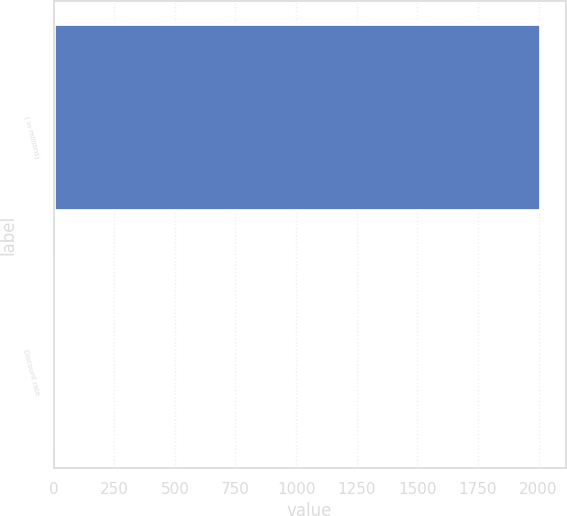Convert chart to OTSL. <chart><loc_0><loc_0><loc_500><loc_500><bar_chart><fcel>( in millions)<fcel>Discount rate<nl><fcel>2011<fcel>4.94<nl></chart> 